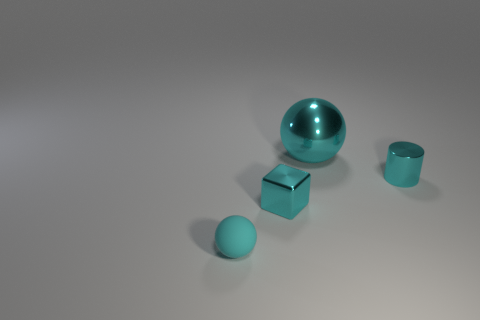Do the cyan metal block and the cylinder have the same size?
Offer a terse response. Yes. What shape is the matte thing that is the same size as the metallic cylinder?
Your answer should be very brief. Sphere. Is the size of the metal thing to the left of the cyan shiny sphere the same as the tiny cylinder?
Give a very brief answer. Yes. There is a cube that is the same size as the cyan cylinder; what is it made of?
Give a very brief answer. Metal. Is there a small shiny cylinder that is on the right side of the cyan ball that is to the right of the cyan metallic thing left of the big metallic thing?
Offer a terse response. Yes. Are there any other things that are the same shape as the tiny rubber object?
Your answer should be very brief. Yes. Do the ball on the left side of the large cyan sphere and the ball behind the small cyan matte thing have the same color?
Give a very brief answer. Yes. Are there any cyan spheres?
Your response must be concise. Yes. What material is the large ball that is the same color as the metal block?
Ensure brevity in your answer.  Metal. What size is the cyan ball in front of the sphere that is to the right of the sphere in front of the tiny cylinder?
Offer a terse response. Small. 